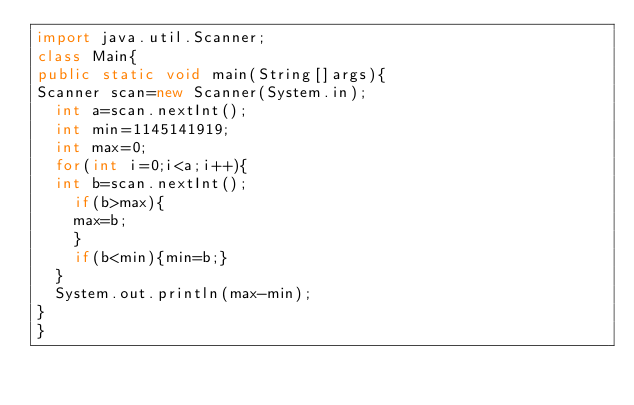Convert code to text. <code><loc_0><loc_0><loc_500><loc_500><_Java_>import java.util.Scanner;
class Main{
public static void main(String[]args){
Scanner scan=new Scanner(System.in);
  int a=scan.nextInt();
  int min=1145141919;
  int max=0;
  for(int i=0;i<a;i++){
  int b=scan.nextInt();
    if(b>max){
    max=b;
    }
    if(b<min){min=b;}
  }
  System.out.println(max-min);
}
}</code> 